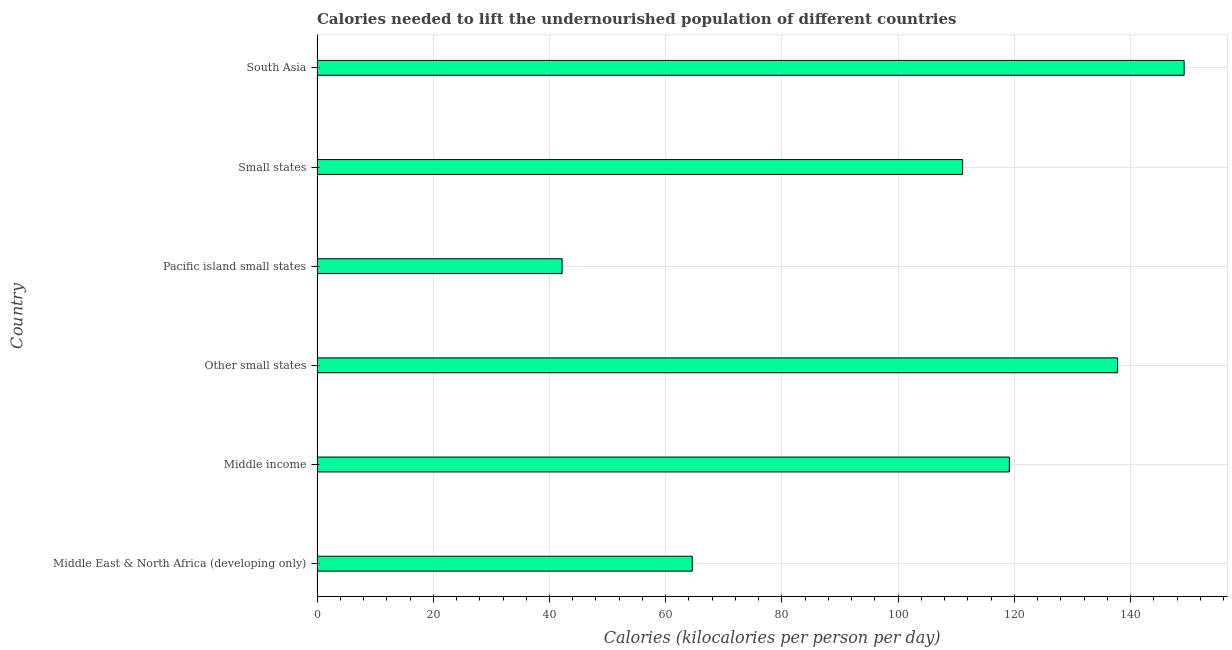Does the graph contain any zero values?
Offer a terse response. No. Does the graph contain grids?
Provide a succinct answer. Yes. What is the title of the graph?
Provide a succinct answer. Calories needed to lift the undernourished population of different countries. What is the label or title of the X-axis?
Provide a succinct answer. Calories (kilocalories per person per day). What is the label or title of the Y-axis?
Ensure brevity in your answer.  Country. What is the depth of food deficit in Middle income?
Give a very brief answer. 119.14. Across all countries, what is the maximum depth of food deficit?
Offer a terse response. 149.21. Across all countries, what is the minimum depth of food deficit?
Make the answer very short. 42.17. In which country was the depth of food deficit minimum?
Provide a succinct answer. Pacific island small states. What is the sum of the depth of food deficit?
Ensure brevity in your answer.  623.95. What is the difference between the depth of food deficit in Middle East & North Africa (developing only) and Other small states?
Ensure brevity in your answer.  -73.19. What is the average depth of food deficit per country?
Your response must be concise. 103.99. What is the median depth of food deficit?
Offer a terse response. 115.12. What is the ratio of the depth of food deficit in Middle East & North Africa (developing only) to that in Other small states?
Offer a terse response. 0.47. Is the difference between the depth of food deficit in Middle income and South Asia greater than the difference between any two countries?
Your response must be concise. No. What is the difference between the highest and the second highest depth of food deficit?
Provide a succinct answer. 11.45. What is the difference between the highest and the lowest depth of food deficit?
Give a very brief answer. 107.04. In how many countries, is the depth of food deficit greater than the average depth of food deficit taken over all countries?
Keep it short and to the point. 4. How many bars are there?
Keep it short and to the point. 6. Are the values on the major ticks of X-axis written in scientific E-notation?
Ensure brevity in your answer.  No. What is the Calories (kilocalories per person per day) in Middle East & North Africa (developing only)?
Your answer should be very brief. 64.57. What is the Calories (kilocalories per person per day) in Middle income?
Your answer should be compact. 119.14. What is the Calories (kilocalories per person per day) in Other small states?
Ensure brevity in your answer.  137.76. What is the Calories (kilocalories per person per day) of Pacific island small states?
Offer a very short reply. 42.17. What is the Calories (kilocalories per person per day) of Small states?
Your response must be concise. 111.1. What is the Calories (kilocalories per person per day) in South Asia?
Your response must be concise. 149.21. What is the difference between the Calories (kilocalories per person per day) in Middle East & North Africa (developing only) and Middle income?
Your answer should be very brief. -54.56. What is the difference between the Calories (kilocalories per person per day) in Middle East & North Africa (developing only) and Other small states?
Ensure brevity in your answer.  -73.19. What is the difference between the Calories (kilocalories per person per day) in Middle East & North Africa (developing only) and Pacific island small states?
Ensure brevity in your answer.  22.4. What is the difference between the Calories (kilocalories per person per day) in Middle East & North Africa (developing only) and Small states?
Offer a terse response. -46.52. What is the difference between the Calories (kilocalories per person per day) in Middle East & North Africa (developing only) and South Asia?
Keep it short and to the point. -84.64. What is the difference between the Calories (kilocalories per person per day) in Middle income and Other small states?
Your response must be concise. -18.62. What is the difference between the Calories (kilocalories per person per day) in Middle income and Pacific island small states?
Give a very brief answer. 76.97. What is the difference between the Calories (kilocalories per person per day) in Middle income and Small states?
Ensure brevity in your answer.  8.04. What is the difference between the Calories (kilocalories per person per day) in Middle income and South Asia?
Provide a succinct answer. -30.08. What is the difference between the Calories (kilocalories per person per day) in Other small states and Pacific island small states?
Make the answer very short. 95.59. What is the difference between the Calories (kilocalories per person per day) in Other small states and Small states?
Your answer should be very brief. 26.67. What is the difference between the Calories (kilocalories per person per day) in Other small states and South Asia?
Your answer should be very brief. -11.45. What is the difference between the Calories (kilocalories per person per day) in Pacific island small states and Small states?
Your response must be concise. -68.92. What is the difference between the Calories (kilocalories per person per day) in Pacific island small states and South Asia?
Your response must be concise. -107.04. What is the difference between the Calories (kilocalories per person per day) in Small states and South Asia?
Provide a short and direct response. -38.12. What is the ratio of the Calories (kilocalories per person per day) in Middle East & North Africa (developing only) to that in Middle income?
Offer a very short reply. 0.54. What is the ratio of the Calories (kilocalories per person per day) in Middle East & North Africa (developing only) to that in Other small states?
Give a very brief answer. 0.47. What is the ratio of the Calories (kilocalories per person per day) in Middle East & North Africa (developing only) to that in Pacific island small states?
Provide a short and direct response. 1.53. What is the ratio of the Calories (kilocalories per person per day) in Middle East & North Africa (developing only) to that in Small states?
Your answer should be compact. 0.58. What is the ratio of the Calories (kilocalories per person per day) in Middle East & North Africa (developing only) to that in South Asia?
Give a very brief answer. 0.43. What is the ratio of the Calories (kilocalories per person per day) in Middle income to that in Other small states?
Provide a succinct answer. 0.86. What is the ratio of the Calories (kilocalories per person per day) in Middle income to that in Pacific island small states?
Your answer should be compact. 2.83. What is the ratio of the Calories (kilocalories per person per day) in Middle income to that in Small states?
Offer a very short reply. 1.07. What is the ratio of the Calories (kilocalories per person per day) in Middle income to that in South Asia?
Give a very brief answer. 0.8. What is the ratio of the Calories (kilocalories per person per day) in Other small states to that in Pacific island small states?
Provide a short and direct response. 3.27. What is the ratio of the Calories (kilocalories per person per day) in Other small states to that in Small states?
Give a very brief answer. 1.24. What is the ratio of the Calories (kilocalories per person per day) in Other small states to that in South Asia?
Make the answer very short. 0.92. What is the ratio of the Calories (kilocalories per person per day) in Pacific island small states to that in Small states?
Your answer should be very brief. 0.38. What is the ratio of the Calories (kilocalories per person per day) in Pacific island small states to that in South Asia?
Your answer should be compact. 0.28. What is the ratio of the Calories (kilocalories per person per day) in Small states to that in South Asia?
Provide a succinct answer. 0.74. 